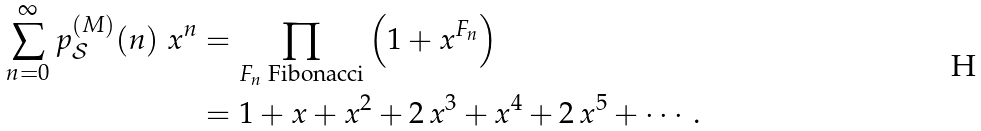<formula> <loc_0><loc_0><loc_500><loc_500>\sum _ { n = 0 } ^ { \infty } p _ { \mathcal { S } } ^ { ( M ) } ( n ) \ x ^ { n } & = \prod _ { \text {$F_{n}$ Fibonacci} } \left ( 1 + x ^ { F _ { n } } \right ) \\ & = 1 + x + x ^ { 2 } + 2 \, x ^ { 3 } + x ^ { 4 } + 2 \, x ^ { 5 } + \cdots .</formula> 